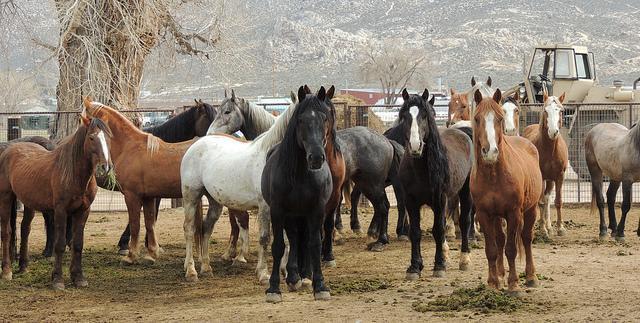How many horses are in the picture?
Give a very brief answer. 10. 